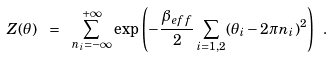<formula> <loc_0><loc_0><loc_500><loc_500>Z ( \theta ) \ = \ \sum _ { n _ { i } = - \infty } ^ { + \infty } \exp { \left ( - \frac { \beta _ { e f f } } { 2 } \sum _ { i = 1 , 2 } ( \theta _ { i } - 2 \pi n _ { i } ) ^ { 2 } \right ) } \ .</formula> 